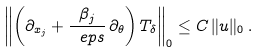Convert formula to latex. <formula><loc_0><loc_0><loc_500><loc_500>\left \| \left ( \partial _ { x _ { j } } + \frac { \beta _ { j } } { \ e p s } \, \partial _ { \theta } \right ) T _ { \delta } \right \| _ { 0 } \leq C \, \| u \| _ { 0 } \, .</formula> 